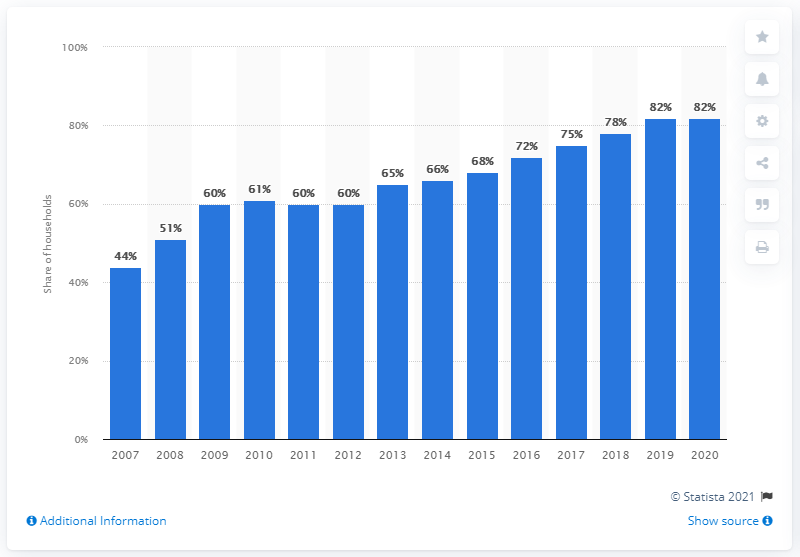List a handful of essential elements in this visual. In 2020, 82% of Lithuanian households had internet access. The internet was not accessed by households in Lithuania in the year 2019. 